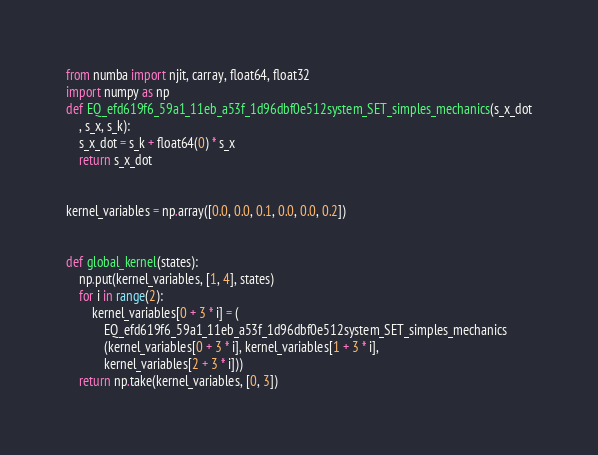<code> <loc_0><loc_0><loc_500><loc_500><_Python_>from numba import njit, carray, float64, float32
import numpy as np
def EQ_efd619f6_59a1_11eb_a53f_1d96dbf0e512system_SET_simples_mechanics(s_x_dot
    , s_x, s_k):
    s_x_dot = s_k + float64(0) * s_x
    return s_x_dot


kernel_variables = np.array([0.0, 0.0, 0.1, 0.0, 0.0, 0.2])


def global_kernel(states):
    np.put(kernel_variables, [1, 4], states)
    for i in range(2):
        kernel_variables[0 + 3 * i] = (
            EQ_efd619f6_59a1_11eb_a53f_1d96dbf0e512system_SET_simples_mechanics
            (kernel_variables[0 + 3 * i], kernel_variables[1 + 3 * i],
            kernel_variables[2 + 3 * i]))
    return np.take(kernel_variables, [0, 3])
</code> 